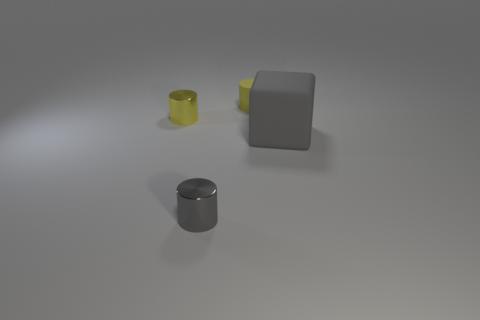Add 2 large blue cylinders. How many objects exist? 6 Subtract all cylinders. How many objects are left? 1 Add 1 tiny metallic cylinders. How many tiny metallic cylinders are left? 3 Add 2 yellow cylinders. How many yellow cylinders exist? 4 Subtract 0 brown blocks. How many objects are left? 4 Subtract all gray matte cubes. Subtract all yellow rubber cylinders. How many objects are left? 2 